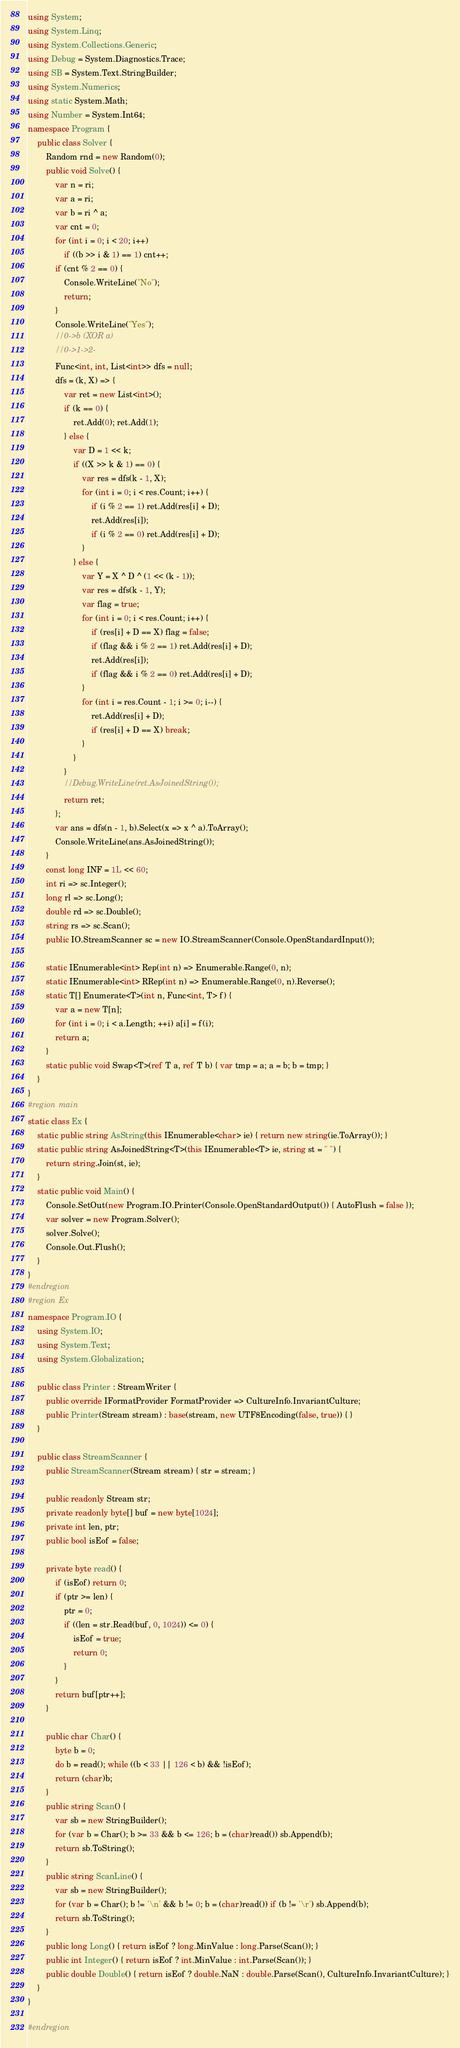Convert code to text. <code><loc_0><loc_0><loc_500><loc_500><_C#_>using System;
using System.Linq;
using System.Collections.Generic;
using Debug = System.Diagnostics.Trace;
using SB = System.Text.StringBuilder;
using System.Numerics;
using static System.Math;
using Number = System.Int64;
namespace Program {
    public class Solver {
        Random rnd = new Random(0);
        public void Solve() {
            var n = ri;
            var a = ri;
            var b = ri ^ a;
            var cnt = 0;
            for (int i = 0; i < 20; i++)
                if ((b >> i & 1) == 1) cnt++;
            if (cnt % 2 == 0) {
                Console.WriteLine("No");
                return;
            }
            Console.WriteLine("Yes");
            //0->b (XOR a)
            //0->1->2-
            Func<int, int, List<int>> dfs = null;
            dfs = (k, X) => {
                var ret = new List<int>();
                if (k == 0) {
                    ret.Add(0); ret.Add(1);
                } else {
                    var D = 1 << k;
                    if ((X >> k & 1) == 0) {
                        var res = dfs(k - 1, X);
                        for (int i = 0; i < res.Count; i++) {
                            if (i % 2 == 1) ret.Add(res[i] + D);
                            ret.Add(res[i]);
                            if (i % 2 == 0) ret.Add(res[i] + D);
                        }
                    } else {
                        var Y = X ^ D ^ (1 << (k - 1));
                        var res = dfs(k - 1, Y);
                        var flag = true;
                        for (int i = 0; i < res.Count; i++) {
                            if (res[i] + D == X) flag = false;
                            if (flag && i % 2 == 1) ret.Add(res[i] + D);
                            ret.Add(res[i]);
                            if (flag && i % 2 == 0) ret.Add(res[i] + D);
                        }
                        for (int i = res.Count - 1; i >= 0; i--) {
                            ret.Add(res[i] + D);
                            if (res[i] + D == X) break;
                        }
                    }
                }
                //Debug.WriteLine(ret.AsJoinedString());
                return ret;
            };
            var ans = dfs(n - 1, b).Select(x => x ^ a).ToArray();
            Console.WriteLine(ans.AsJoinedString());
        }
        const long INF = 1L << 60;
        int ri => sc.Integer();
        long rl => sc.Long();
        double rd => sc.Double();
        string rs => sc.Scan();
        public IO.StreamScanner sc = new IO.StreamScanner(Console.OpenStandardInput());

        static IEnumerable<int> Rep(int n) => Enumerable.Range(0, n);
        static IEnumerable<int> RRep(int n) => Enumerable.Range(0, n).Reverse();
        static T[] Enumerate<T>(int n, Func<int, T> f) {
            var a = new T[n];
            for (int i = 0; i < a.Length; ++i) a[i] = f(i);
            return a;
        }
        static public void Swap<T>(ref T a, ref T b) { var tmp = a; a = b; b = tmp; }
    }
}
#region main
static class Ex {
    static public string AsString(this IEnumerable<char> ie) { return new string(ie.ToArray()); }
    static public string AsJoinedString<T>(this IEnumerable<T> ie, string st = " ") {
        return string.Join(st, ie);
    }
    static public void Main() {
        Console.SetOut(new Program.IO.Printer(Console.OpenStandardOutput()) { AutoFlush = false });
        var solver = new Program.Solver();
        solver.Solve();
        Console.Out.Flush();
    }
}
#endregion
#region Ex
namespace Program.IO {
    using System.IO;
    using System.Text;
    using System.Globalization;

    public class Printer : StreamWriter {
        public override IFormatProvider FormatProvider => CultureInfo.InvariantCulture;
        public Printer(Stream stream) : base(stream, new UTF8Encoding(false, true)) { }
    }

    public class StreamScanner {
        public StreamScanner(Stream stream) { str = stream; }

        public readonly Stream str;
        private readonly byte[] buf = new byte[1024];
        private int len, ptr;
        public bool isEof = false;

        private byte read() {
            if (isEof) return 0;
            if (ptr >= len) {
                ptr = 0;
                if ((len = str.Read(buf, 0, 1024)) <= 0) {
                    isEof = true;
                    return 0;
                }
            }
            return buf[ptr++];
        }

        public char Char() {
            byte b = 0;
            do b = read(); while ((b < 33 || 126 < b) && !isEof);
            return (char)b;
        }
        public string Scan() {
            var sb = new StringBuilder();
            for (var b = Char(); b >= 33 && b <= 126; b = (char)read()) sb.Append(b);
            return sb.ToString();
        }
        public string ScanLine() {
            var sb = new StringBuilder();
            for (var b = Char(); b != '\n' && b != 0; b = (char)read()) if (b != '\r') sb.Append(b);
            return sb.ToString();
        }
        public long Long() { return isEof ? long.MinValue : long.Parse(Scan()); }
        public int Integer() { return isEof ? int.MinValue : int.Parse(Scan()); }
        public double Double() { return isEof ? double.NaN : double.Parse(Scan(), CultureInfo.InvariantCulture); }
    }
}

#endregion
</code> 